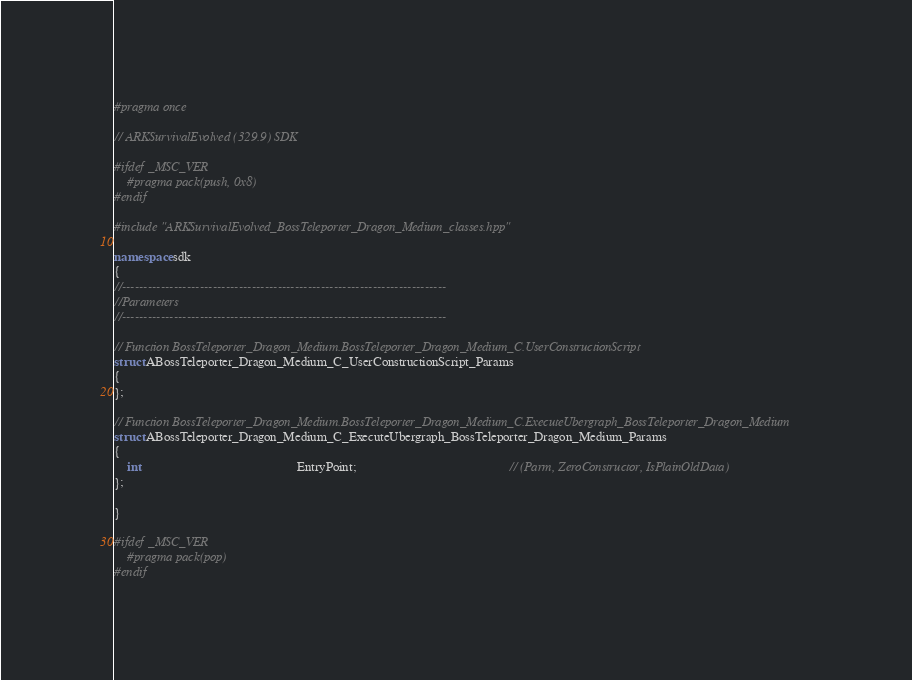Convert code to text. <code><loc_0><loc_0><loc_500><loc_500><_C++_>#pragma once

// ARKSurvivalEvolved (329.9) SDK

#ifdef _MSC_VER
	#pragma pack(push, 0x8)
#endif

#include "ARKSurvivalEvolved_BossTeleporter_Dragon_Medium_classes.hpp"

namespace sdk
{
//---------------------------------------------------------------------------
//Parameters
//---------------------------------------------------------------------------

// Function BossTeleporter_Dragon_Medium.BossTeleporter_Dragon_Medium_C.UserConstructionScript
struct ABossTeleporter_Dragon_Medium_C_UserConstructionScript_Params
{
};

// Function BossTeleporter_Dragon_Medium.BossTeleporter_Dragon_Medium_C.ExecuteUbergraph_BossTeleporter_Dragon_Medium
struct ABossTeleporter_Dragon_Medium_C_ExecuteUbergraph_BossTeleporter_Dragon_Medium_Params
{
	int                                                EntryPoint;                                               // (Parm, ZeroConstructor, IsPlainOldData)
};

}

#ifdef _MSC_VER
	#pragma pack(pop)
#endif
</code> 